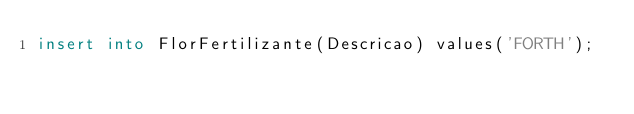<code> <loc_0><loc_0><loc_500><loc_500><_SQL_>insert into FlorFertilizante(Descricao) values('FORTH');
</code> 